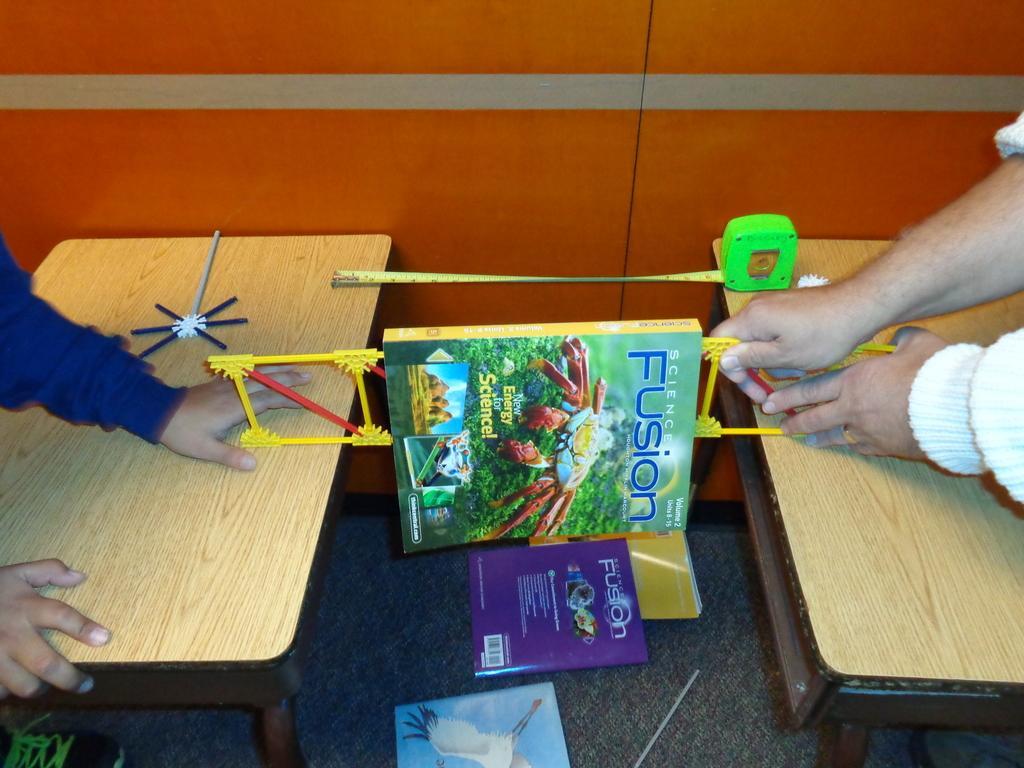Describe this image in one or two sentences. In the image we can see there are two people who are balancing a book and on the floor there are books. 